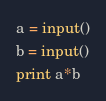Convert code to text. <code><loc_0><loc_0><loc_500><loc_500><_Python_>a = input()
b = input()
print a*b</code> 